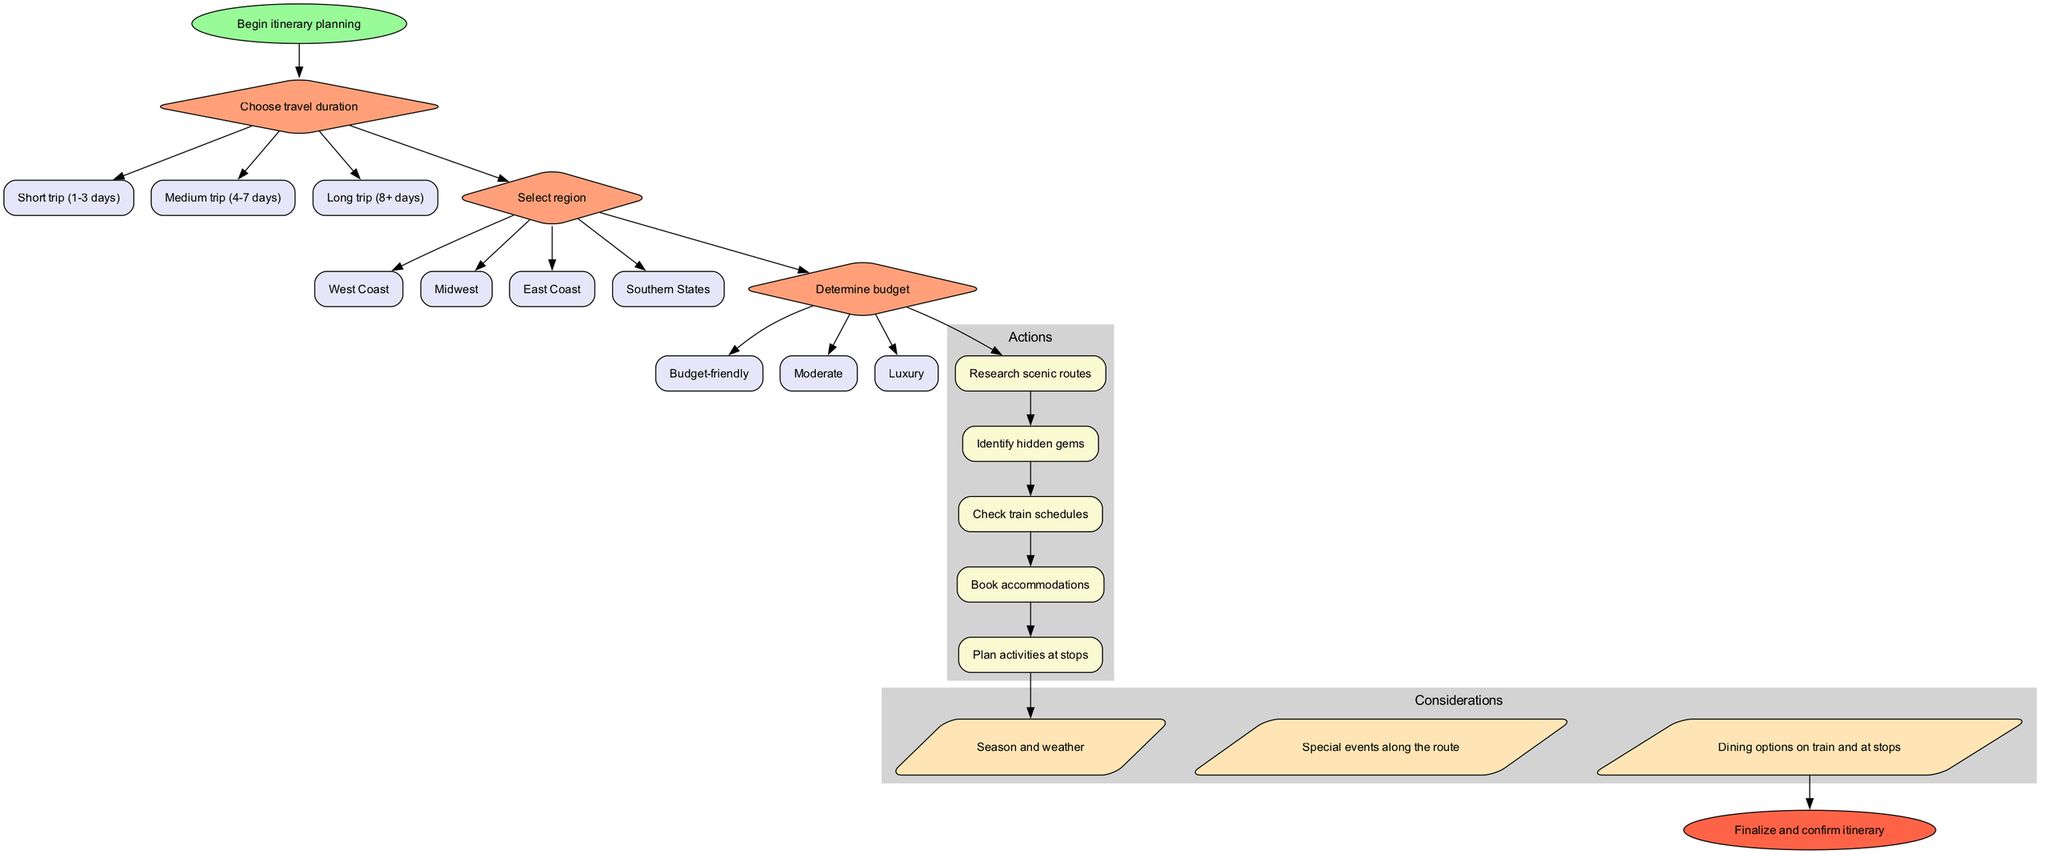What is the starting point of the itinerary? The diagram begins with the node labeled "Begin itinerary planning," which indicates the starting point of the process for creating a custom itinerary.
Answer: Begin itinerary planning How many options are there for the "Choose travel duration" decision? The node labeled "Choose travel duration" has three options listed underneath it: "Short trip (1-3 days)", "Medium trip (4-7 days)", and "Long trip (8+ days)", which makes a total of three options.
Answer: 3 What is the last action before the considerations? The last action node listed before the considerations is "Plan activities at stops." The flow leads from the last action to the first consideration node.
Answer: Plan activities at stops What connects the last decision to the first action? The edge connecting the last decision node ("Determine budget") to the first action node ("Research scenic routes") indicates that once the budget is decided, the planning moves into actions, starting with researching scenic routes.
Answer: Determine budget to Research scenic routes Identify one consideration that should be taken into account while planning. The diagram lists several considerations, one of which is "Season and weather." This is an important factor to consider as it can affect travel experiences and planning.
Answer: Season and weather How many total actions are there in the diagram? There are five action nodes listed under the "Actions" cluster, which are "Research scenic routes," "Identify hidden gems," "Check train schedules," "Book accommodations," and "Plan activities at stops." Therefore, the total number of actions is five.
Answer: 5 What type of node is used for the decisions in the diagram? The nodes for the decisions are shaped like diamonds, which is standard for representing decision points in a flowchart. Each decision in this diagram is depicted with a diamond shape.
Answer: Diamond Which node directly leads to the end of the process? The final consideration node, "Dining options on train and at stops," connects directly to the end node labeled "Finalize and confirm itinerary," indicating that it is the last step before completing the process.
Answer: Dining options on train and at stops 